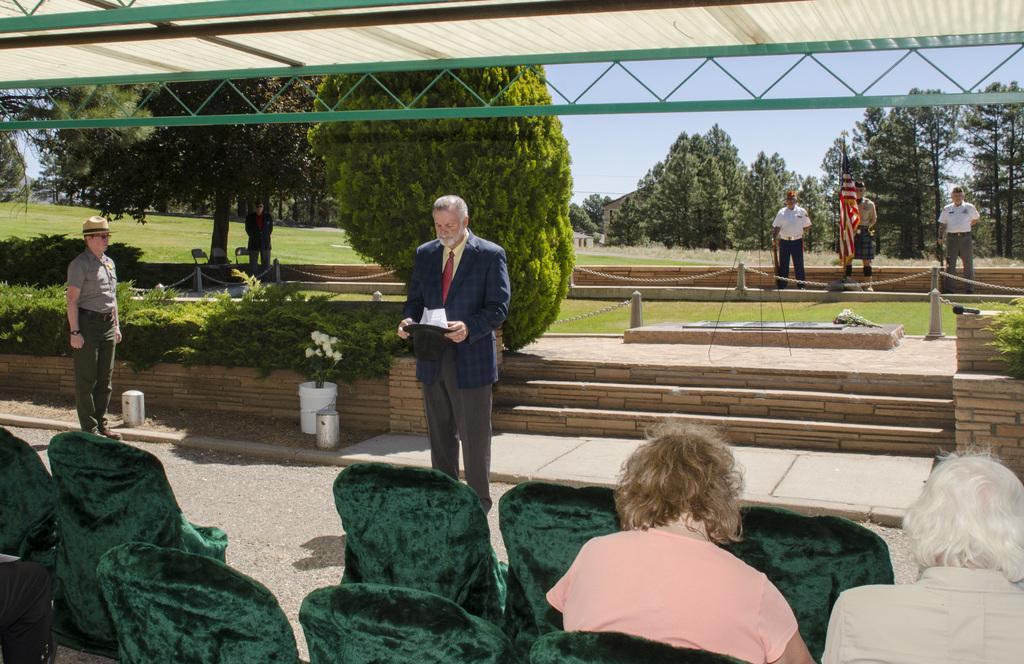Can you describe this image briefly? There are chairs and people sitting in the foreground area of the image, there are trees, grassland, people, flag and the sky in the background. 